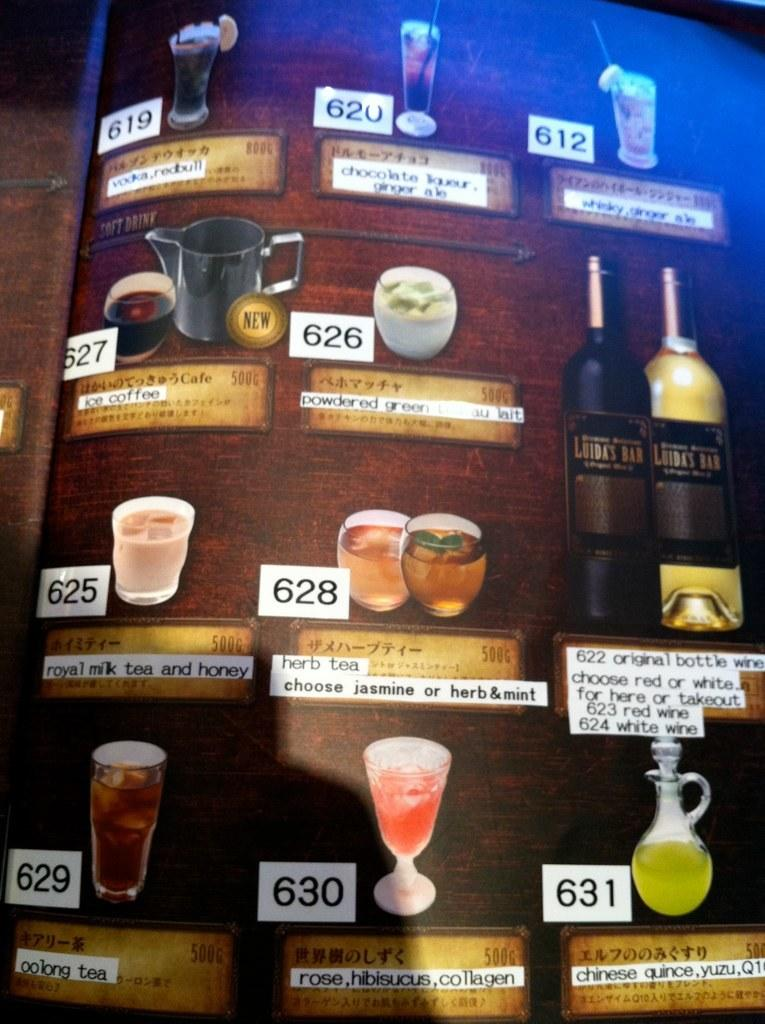<image>
Share a concise interpretation of the image provided. the number 628 is on one of the menu items 